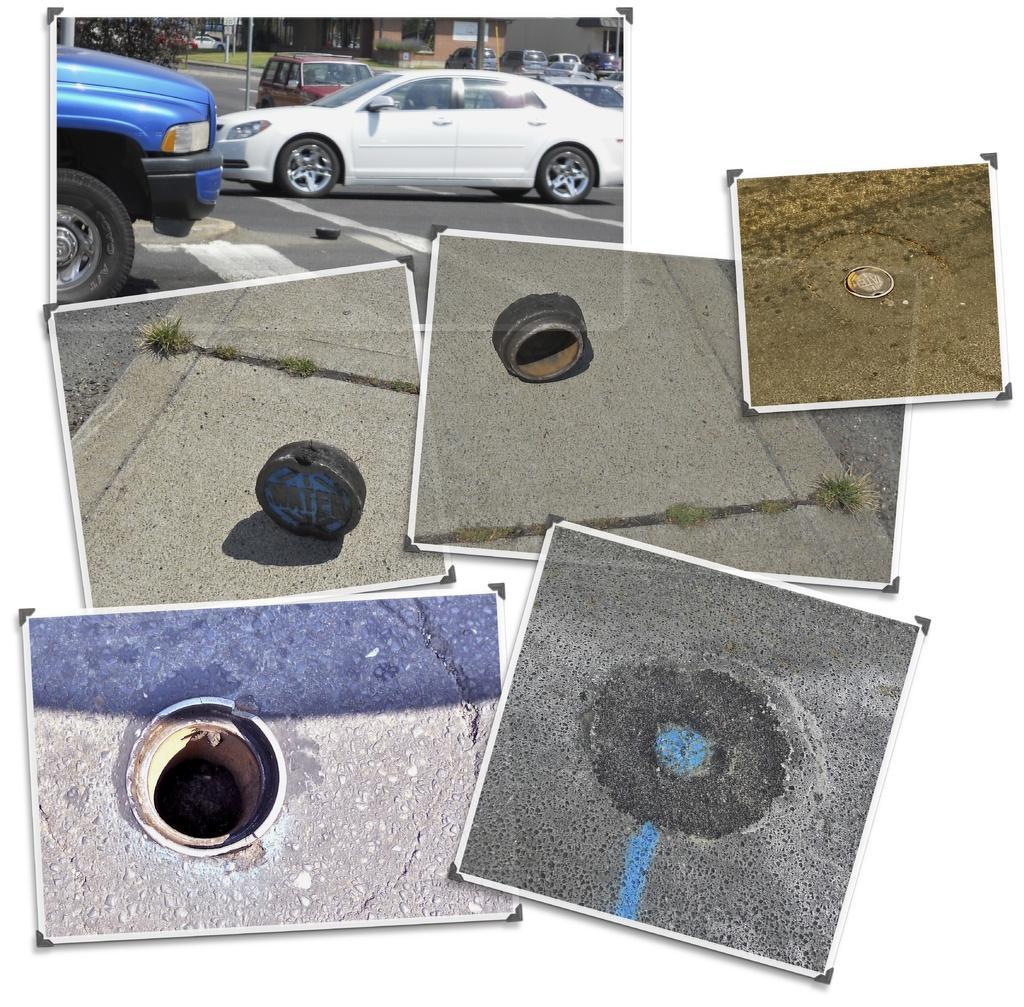In one or two sentences, can you explain what this image depicts? This picture shows few cars on the road and few cars parked and we see buildings and a tree and we see a manhole and its cap and a picture of a opened man hole. 